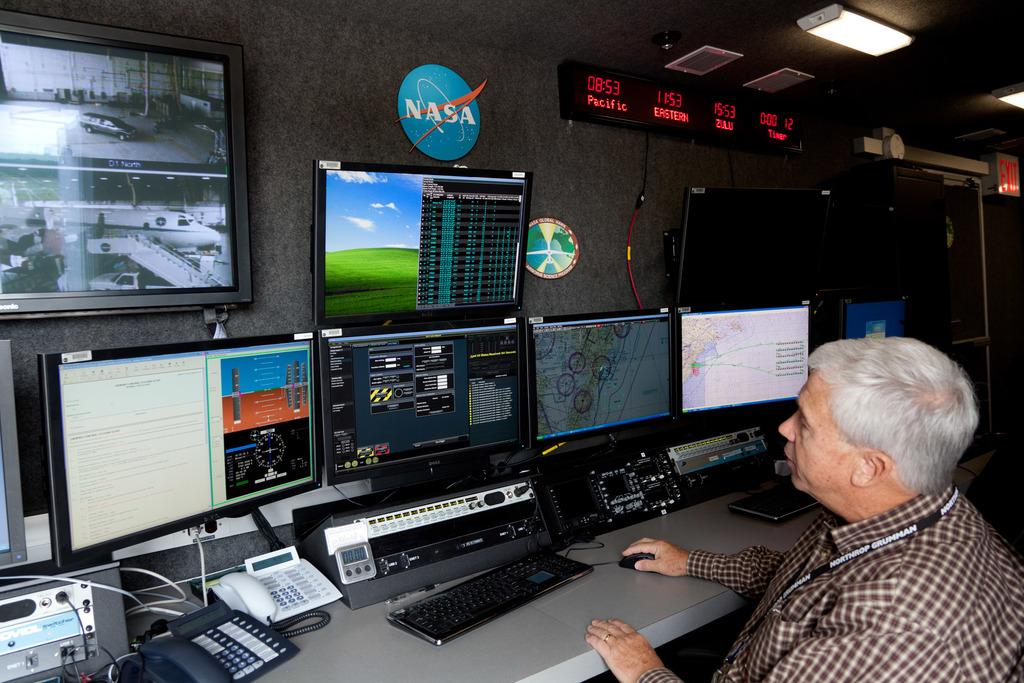<image>
Create a compact narrative representing the image presented. A man in front of several monitors with a NASA sign over his head. 